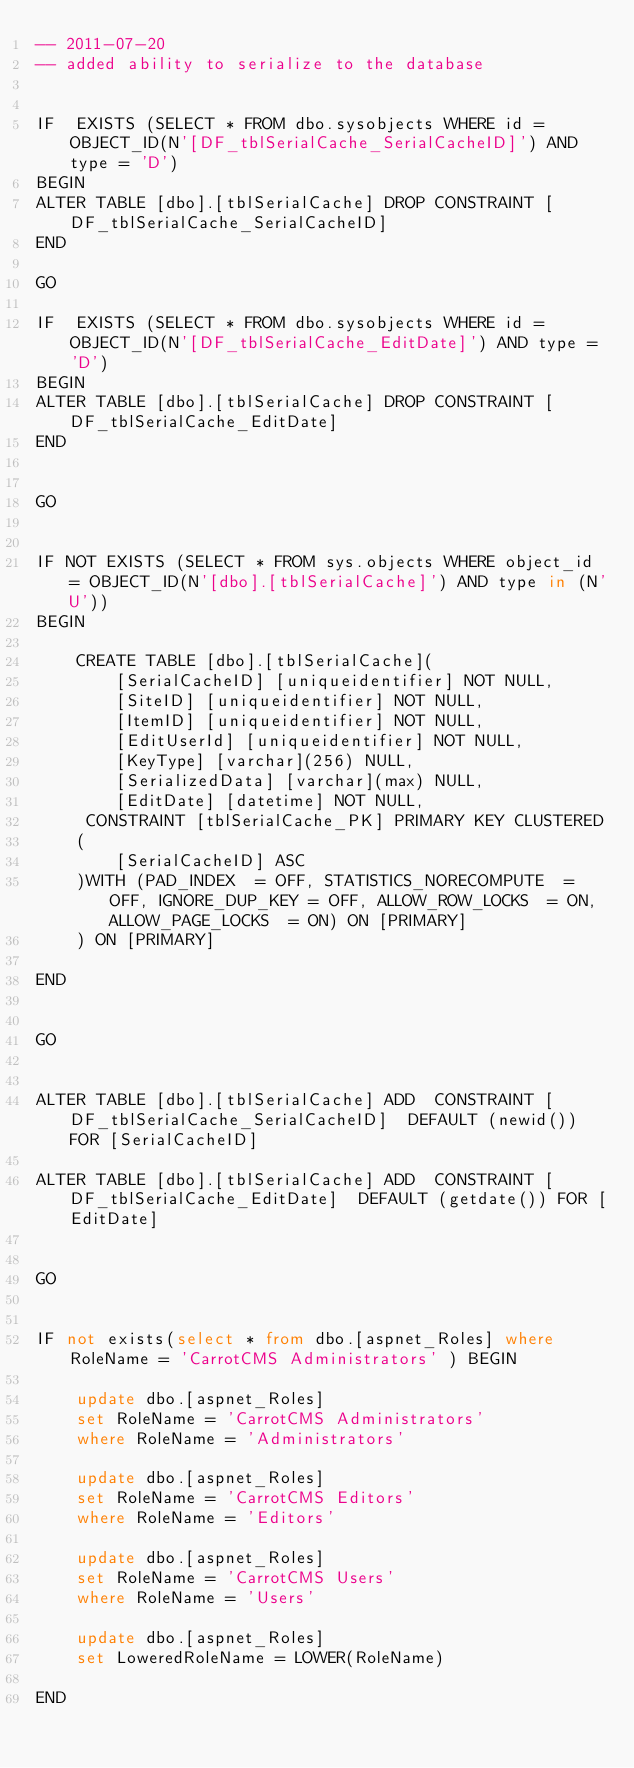<code> <loc_0><loc_0><loc_500><loc_500><_SQL_>-- 2011-07-20
-- added ability to serialize to the database


IF  EXISTS (SELECT * FROM dbo.sysobjects WHERE id = OBJECT_ID(N'[DF_tblSerialCache_SerialCacheID]') AND type = 'D')
BEGIN
ALTER TABLE [dbo].[tblSerialCache] DROP CONSTRAINT [DF_tblSerialCache_SerialCacheID]
END

GO

IF  EXISTS (SELECT * FROM dbo.sysobjects WHERE id = OBJECT_ID(N'[DF_tblSerialCache_EditDate]') AND type = 'D')
BEGIN
ALTER TABLE [dbo].[tblSerialCache] DROP CONSTRAINT [DF_tblSerialCache_EditDate]
END


GO


IF NOT EXISTS (SELECT * FROM sys.objects WHERE object_id = OBJECT_ID(N'[dbo].[tblSerialCache]') AND type in (N'U'))
BEGIN

	CREATE TABLE [dbo].[tblSerialCache](
		[SerialCacheID] [uniqueidentifier] NOT NULL,
		[SiteID] [uniqueidentifier] NOT NULL,
		[ItemID] [uniqueidentifier] NOT NULL,
		[EditUserId] [uniqueidentifier] NOT NULL,
		[KeyType] [varchar](256) NULL,
		[SerializedData] [varchar](max) NULL,
		[EditDate] [datetime] NOT NULL,
	 CONSTRAINT [tblSerialCache_PK] PRIMARY KEY CLUSTERED 
	(
		[SerialCacheID] ASC
	)WITH (PAD_INDEX  = OFF, STATISTICS_NORECOMPUTE  = OFF, IGNORE_DUP_KEY = OFF, ALLOW_ROW_LOCKS  = ON, ALLOW_PAGE_LOCKS  = ON) ON [PRIMARY]
	) ON [PRIMARY]

END


GO


ALTER TABLE [dbo].[tblSerialCache] ADD  CONSTRAINT [DF_tblSerialCache_SerialCacheID]  DEFAULT (newid()) FOR [SerialCacheID]

ALTER TABLE [dbo].[tblSerialCache] ADD  CONSTRAINT [DF_tblSerialCache_EditDate]  DEFAULT (getdate()) FOR [EditDate]


GO


IF not exists(select * from dbo.[aspnet_Roles] where RoleName = 'CarrotCMS Administrators' ) BEGIN	

	update dbo.[aspnet_Roles]
	set RoleName = 'CarrotCMS Administrators'
	where RoleName = 'Administrators'

	update dbo.[aspnet_Roles]
	set RoleName = 'CarrotCMS Editors'
	where RoleName = 'Editors'

	update dbo.[aspnet_Roles]
	set RoleName = 'CarrotCMS Users'
	where RoleName = 'Users'

	update dbo.[aspnet_Roles]
	set LoweredRoleName = LOWER(RoleName)

END	

</code> 